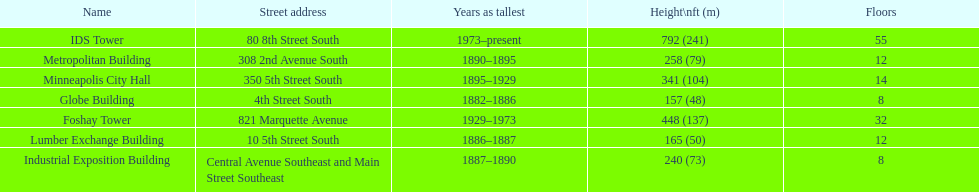Parse the table in full. {'header': ['Name', 'Street address', 'Years as tallest', 'Height\\nft (m)', 'Floors'], 'rows': [['IDS Tower', '80 8th Street South', '1973–present', '792 (241)', '55'], ['Metropolitan Building', '308 2nd Avenue South', '1890–1895', '258 (79)', '12'], ['Minneapolis City Hall', '350 5th Street South', '1895–1929', '341 (104)', '14'], ['Globe Building', '4th Street South', '1882–1886', '157 (48)', '8'], ['Foshay Tower', '821 Marquette Avenue', '1929–1973', '448 (137)', '32'], ['Lumber Exchange Building', '10 5th Street South', '1886–1887', '165 (50)', '12'], ['Industrial Exposition Building', 'Central Avenue Southeast and Main Street Southeast', '1887–1890', '240 (73)', '8']]} Which building has 8 floors and is 240 ft tall? Industrial Exposition Building. 